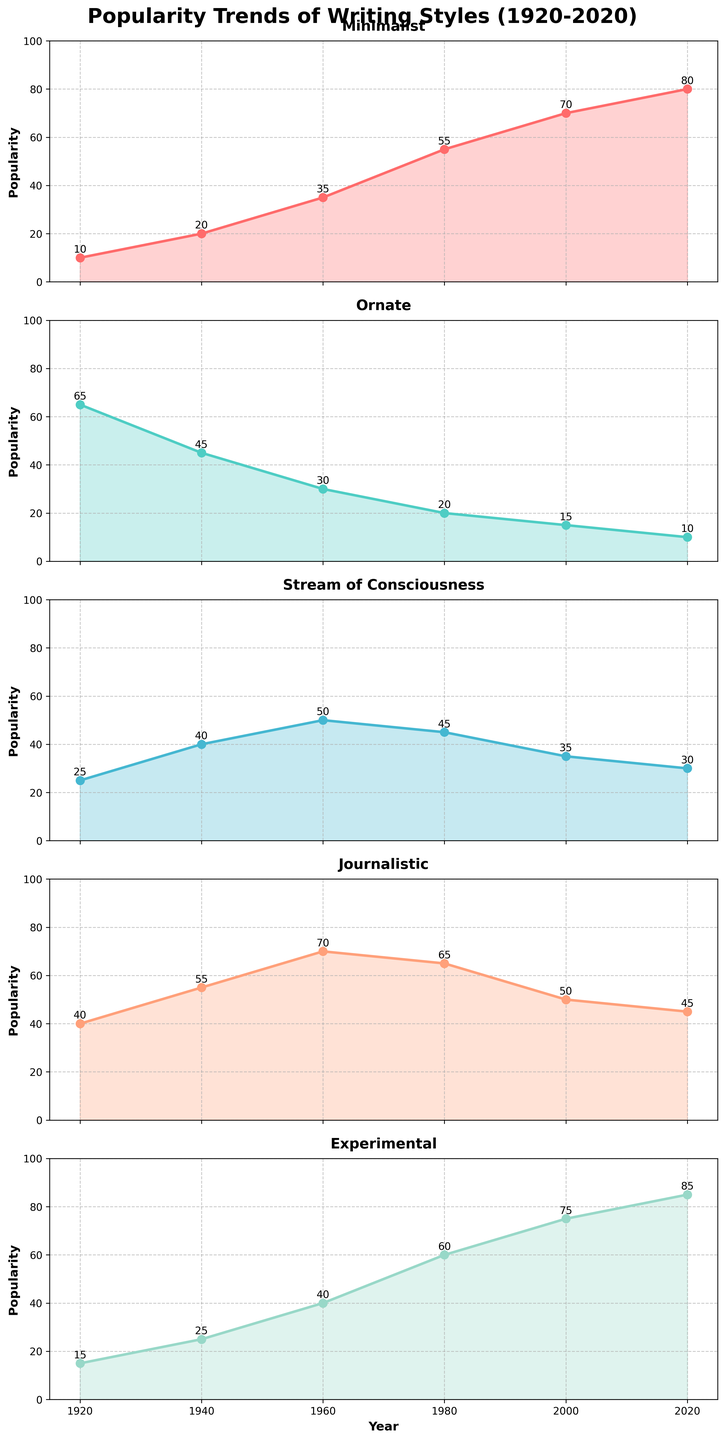What is the title of the figure? The title is usually found at the top of the figure and it summarizes what the figure is about. In this case, the title is "Popularity Trends of Writing Styles (1920-2020)".
Answer: Popularity Trends of Writing Styles (1920-2020) How many subplots are shown in the figure? The figure consists of vertical subplots, and each subplot represents the trend of a different writing style. Counting the number of plots indicates there are 5 subplots.
Answer: 5 Which writing style showed a consistent increase in popularity from 1920 to 2020? By observing the plot lines, the "Minimalist" style shows a continuous upward trend starting from 10 in 1920 to 80 in 2020.
Answer: Minimalist What was the popularity of the Journalistic style in 1980? Locate the Journalistic subplot and find the data point corresponding to the year 1980. The value is marked and labeled as 65.
Answer: 65 Which writing style had the highest popularity value in 2020? Each subplot has its own data points for 2020. The "Experimental" style has the highest value marked as 85.
Answer: Experimental What is the difference in popularity between 'Ornate' and 'Stream of Consciousness' in 1940? Find the values for both writing styles in the year 1940, which are 45 (Ornate) and 40 (Stream of Consciousness). Subtract 40 from 45 to get the difference.
Answer: 5 Did any writing style's popularity decrease over the century? By reviewing the trend lines, the "Ornate" style's popularity decreases continuously from 65 in 1920 to just 10 in 2020.
Answer: Ornate Which years show the largest change in popularity for the Experimental style? Inspect the Experimental subplot and determine the differences between consecutive years. The biggest change occurs between 1980 (60) and 2000 (75), a change of 15.
Answer: 1980 to 2000 What is the average popularity of the Stream of Consciousness style over the 100 years? Add the popularity values for Stream of Consciousness: (25 + 40 + 50 + 45 + 35 + 30). Sum is 225. Divide by the number of data points (6), the average is 37.5.
Answer: 37.5 In which year did the Journalistic style achieve its peak popularity? Locate the highest data point in the Journalistic subplot and note the corresponding year. The peak is at 70 in 1960.
Answer: 1960 